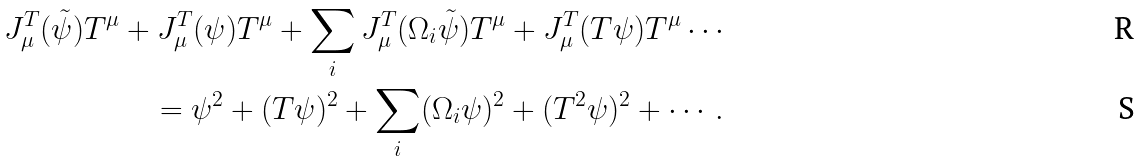Convert formula to latex. <formula><loc_0><loc_0><loc_500><loc_500>J ^ { T } _ { \mu } ( \tilde { \psi } ) T ^ { \mu } + J ^ { T } _ { \mu } ( \psi ) T ^ { \mu } + \sum _ { i } J ^ { T } _ { \mu } ( \Omega _ { i } \tilde { \psi } ) T ^ { \mu } + J ^ { T } _ { \mu } ( T \psi ) T ^ { \mu } \cdots \\ = \psi ^ { 2 } + ( T \psi ) ^ { 2 } + \sum _ { i } ( \Omega _ { i } \psi ) ^ { 2 } + ( T ^ { 2 } \psi ) ^ { 2 } + \cdots .</formula> 